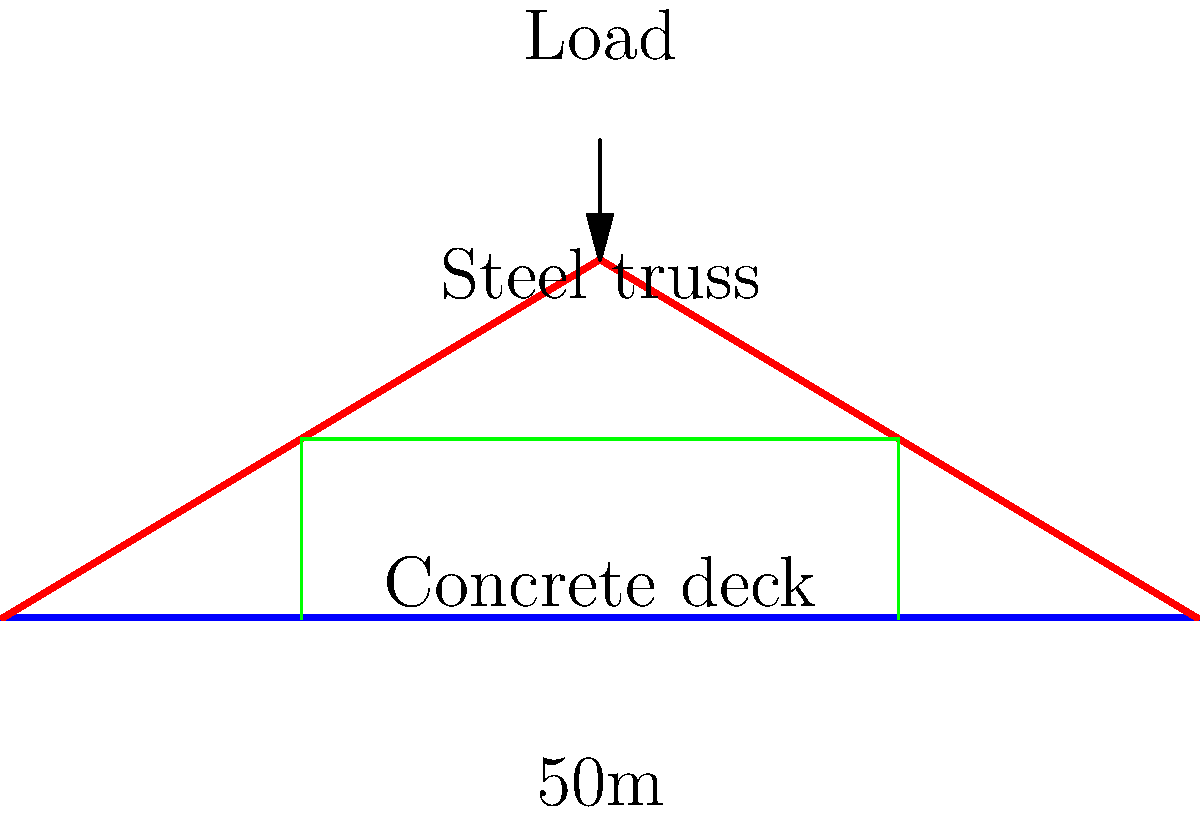While walking across a bridge, you notice its unique structure. The bridge spans 50 meters and consists of a steel truss supporting a concrete deck. If the bridge is designed to safely carry a maximum distributed load of 30 kN/m, what is the total maximum load the bridge can support? To calculate the total maximum load the bridge can support, we need to follow these steps:

1. Identify the given information:
   - Bridge span: 50 meters
   - Maximum distributed load: 30 kN/m

2. Calculate the total load:
   - Total load = Distributed load × Span length
   - Total load = $30 \text{ kN/m} \times 50 \text{ m}$
   - Total load = $1500 \text{ kN}$

3. Convert kN to metric tons:
   - 1 kN ≈ 0.1020 metric tons
   - $1500 \text{ kN} \times 0.1020 = 153 \text{ metric tons}$

Therefore, the bridge can support a total maximum load of 1500 kN or approximately 153 metric tons.
Answer: 1500 kN (153 metric tons) 